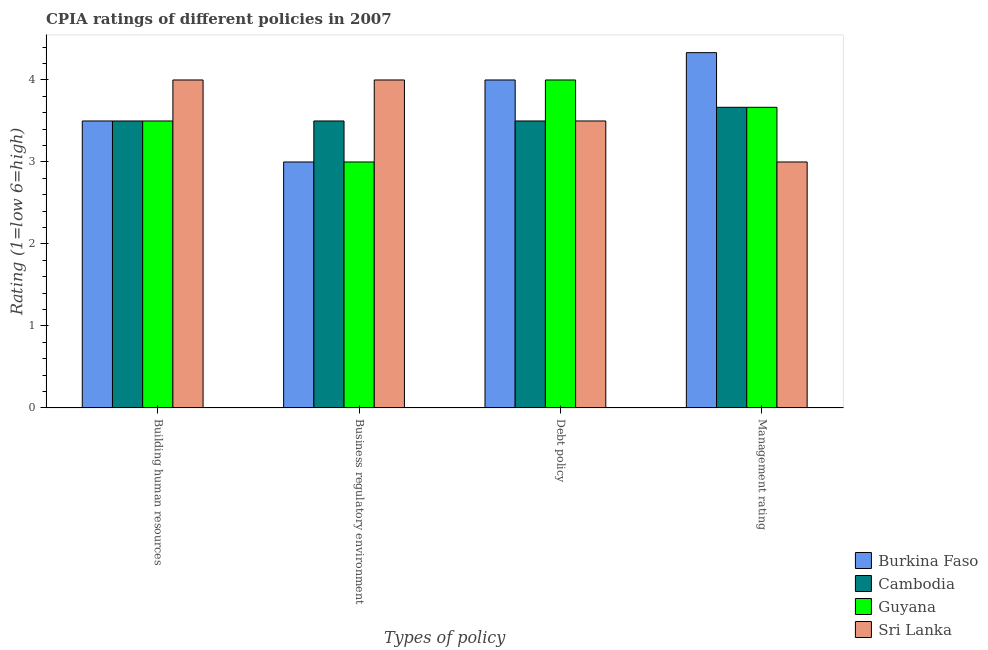How many different coloured bars are there?
Your answer should be very brief. 4. How many groups of bars are there?
Your answer should be compact. 4. How many bars are there on the 2nd tick from the right?
Provide a short and direct response. 4. What is the label of the 2nd group of bars from the left?
Offer a terse response. Business regulatory environment. Across all countries, what is the maximum cpia rating of debt policy?
Provide a short and direct response. 4. Across all countries, what is the minimum cpia rating of management?
Make the answer very short. 3. In which country was the cpia rating of management maximum?
Keep it short and to the point. Burkina Faso. In which country was the cpia rating of building human resources minimum?
Give a very brief answer. Burkina Faso. What is the difference between the cpia rating of building human resources in Sri Lanka and that in Guyana?
Your answer should be very brief. 0.5. What is the difference between the cpia rating of debt policy in Cambodia and the cpia rating of building human resources in Guyana?
Provide a short and direct response. 0. What is the average cpia rating of management per country?
Offer a very short reply. 3.67. In how many countries, is the cpia rating of business regulatory environment greater than 3.6 ?
Offer a very short reply. 1. What is the difference between the highest and the lowest cpia rating of business regulatory environment?
Give a very brief answer. 1. Is the sum of the cpia rating of building human resources in Burkina Faso and Sri Lanka greater than the maximum cpia rating of management across all countries?
Ensure brevity in your answer.  Yes. Is it the case that in every country, the sum of the cpia rating of debt policy and cpia rating of business regulatory environment is greater than the sum of cpia rating of building human resources and cpia rating of management?
Offer a very short reply. No. What does the 4th bar from the left in Building human resources represents?
Your response must be concise. Sri Lanka. What does the 3rd bar from the right in Debt policy represents?
Give a very brief answer. Cambodia. Is it the case that in every country, the sum of the cpia rating of building human resources and cpia rating of business regulatory environment is greater than the cpia rating of debt policy?
Provide a short and direct response. Yes. What is the difference between two consecutive major ticks on the Y-axis?
Ensure brevity in your answer.  1. Are the values on the major ticks of Y-axis written in scientific E-notation?
Keep it short and to the point. No. Does the graph contain any zero values?
Offer a very short reply. No. Does the graph contain grids?
Ensure brevity in your answer.  No. How many legend labels are there?
Ensure brevity in your answer.  4. What is the title of the graph?
Give a very brief answer. CPIA ratings of different policies in 2007. What is the label or title of the X-axis?
Ensure brevity in your answer.  Types of policy. What is the label or title of the Y-axis?
Make the answer very short. Rating (1=low 6=high). What is the Rating (1=low 6=high) of Cambodia in Building human resources?
Ensure brevity in your answer.  3.5. What is the Rating (1=low 6=high) of Burkina Faso in Business regulatory environment?
Your answer should be very brief. 3. What is the Rating (1=low 6=high) of Cambodia in Business regulatory environment?
Keep it short and to the point. 3.5. What is the Rating (1=low 6=high) of Sri Lanka in Business regulatory environment?
Your response must be concise. 4. What is the Rating (1=low 6=high) of Cambodia in Debt policy?
Keep it short and to the point. 3.5. What is the Rating (1=low 6=high) in Sri Lanka in Debt policy?
Ensure brevity in your answer.  3.5. What is the Rating (1=low 6=high) of Burkina Faso in Management rating?
Give a very brief answer. 4.33. What is the Rating (1=low 6=high) in Cambodia in Management rating?
Your answer should be very brief. 3.67. What is the Rating (1=low 6=high) in Guyana in Management rating?
Your response must be concise. 3.67. What is the Rating (1=low 6=high) in Sri Lanka in Management rating?
Your answer should be compact. 3. Across all Types of policy, what is the maximum Rating (1=low 6=high) of Burkina Faso?
Your response must be concise. 4.33. Across all Types of policy, what is the maximum Rating (1=low 6=high) of Cambodia?
Your answer should be compact. 3.67. Across all Types of policy, what is the maximum Rating (1=low 6=high) of Guyana?
Offer a terse response. 4. Across all Types of policy, what is the minimum Rating (1=low 6=high) of Cambodia?
Keep it short and to the point. 3.5. Across all Types of policy, what is the minimum Rating (1=low 6=high) of Guyana?
Provide a short and direct response. 3. What is the total Rating (1=low 6=high) in Burkina Faso in the graph?
Offer a very short reply. 14.83. What is the total Rating (1=low 6=high) of Cambodia in the graph?
Make the answer very short. 14.17. What is the total Rating (1=low 6=high) of Guyana in the graph?
Your answer should be very brief. 14.17. What is the difference between the Rating (1=low 6=high) of Burkina Faso in Building human resources and that in Business regulatory environment?
Your answer should be very brief. 0.5. What is the difference between the Rating (1=low 6=high) of Guyana in Building human resources and that in Business regulatory environment?
Your answer should be very brief. 0.5. What is the difference between the Rating (1=low 6=high) of Burkina Faso in Building human resources and that in Debt policy?
Provide a short and direct response. -0.5. What is the difference between the Rating (1=low 6=high) in Guyana in Building human resources and that in Debt policy?
Offer a very short reply. -0.5. What is the difference between the Rating (1=low 6=high) in Sri Lanka in Building human resources and that in Debt policy?
Your answer should be very brief. 0.5. What is the difference between the Rating (1=low 6=high) of Guyana in Building human resources and that in Management rating?
Give a very brief answer. -0.17. What is the difference between the Rating (1=low 6=high) in Burkina Faso in Business regulatory environment and that in Debt policy?
Keep it short and to the point. -1. What is the difference between the Rating (1=low 6=high) of Burkina Faso in Business regulatory environment and that in Management rating?
Your answer should be compact. -1.33. What is the difference between the Rating (1=low 6=high) in Cambodia in Business regulatory environment and that in Management rating?
Your response must be concise. -0.17. What is the difference between the Rating (1=low 6=high) of Burkina Faso in Debt policy and that in Management rating?
Keep it short and to the point. -0.33. What is the difference between the Rating (1=low 6=high) of Cambodia in Debt policy and that in Management rating?
Your answer should be compact. -0.17. What is the difference between the Rating (1=low 6=high) in Guyana in Debt policy and that in Management rating?
Your response must be concise. 0.33. What is the difference between the Rating (1=low 6=high) in Sri Lanka in Debt policy and that in Management rating?
Give a very brief answer. 0.5. What is the difference between the Rating (1=low 6=high) of Burkina Faso in Building human resources and the Rating (1=low 6=high) of Cambodia in Business regulatory environment?
Ensure brevity in your answer.  0. What is the difference between the Rating (1=low 6=high) of Burkina Faso in Building human resources and the Rating (1=low 6=high) of Guyana in Business regulatory environment?
Your answer should be compact. 0.5. What is the difference between the Rating (1=low 6=high) in Cambodia in Building human resources and the Rating (1=low 6=high) in Guyana in Business regulatory environment?
Give a very brief answer. 0.5. What is the difference between the Rating (1=low 6=high) in Cambodia in Building human resources and the Rating (1=low 6=high) in Sri Lanka in Business regulatory environment?
Ensure brevity in your answer.  -0.5. What is the difference between the Rating (1=low 6=high) of Burkina Faso in Building human resources and the Rating (1=low 6=high) of Guyana in Management rating?
Offer a terse response. -0.17. What is the difference between the Rating (1=low 6=high) in Burkina Faso in Building human resources and the Rating (1=low 6=high) in Sri Lanka in Management rating?
Ensure brevity in your answer.  0.5. What is the difference between the Rating (1=low 6=high) in Burkina Faso in Business regulatory environment and the Rating (1=low 6=high) in Cambodia in Debt policy?
Ensure brevity in your answer.  -0.5. What is the difference between the Rating (1=low 6=high) in Cambodia in Business regulatory environment and the Rating (1=low 6=high) in Sri Lanka in Debt policy?
Your response must be concise. 0. What is the difference between the Rating (1=low 6=high) in Guyana in Business regulatory environment and the Rating (1=low 6=high) in Sri Lanka in Debt policy?
Make the answer very short. -0.5. What is the difference between the Rating (1=low 6=high) of Burkina Faso in Business regulatory environment and the Rating (1=low 6=high) of Cambodia in Management rating?
Your answer should be very brief. -0.67. What is the difference between the Rating (1=low 6=high) in Burkina Faso in Business regulatory environment and the Rating (1=low 6=high) in Sri Lanka in Management rating?
Your answer should be very brief. 0. What is the difference between the Rating (1=low 6=high) in Cambodia in Business regulatory environment and the Rating (1=low 6=high) in Sri Lanka in Management rating?
Offer a very short reply. 0.5. What is the difference between the Rating (1=low 6=high) in Burkina Faso in Debt policy and the Rating (1=low 6=high) in Cambodia in Management rating?
Ensure brevity in your answer.  0.33. What is the difference between the Rating (1=low 6=high) of Burkina Faso in Debt policy and the Rating (1=low 6=high) of Guyana in Management rating?
Your answer should be very brief. 0.33. What is the difference between the Rating (1=low 6=high) in Burkina Faso in Debt policy and the Rating (1=low 6=high) in Sri Lanka in Management rating?
Provide a short and direct response. 1. What is the average Rating (1=low 6=high) in Burkina Faso per Types of policy?
Offer a very short reply. 3.71. What is the average Rating (1=low 6=high) in Cambodia per Types of policy?
Offer a very short reply. 3.54. What is the average Rating (1=low 6=high) of Guyana per Types of policy?
Ensure brevity in your answer.  3.54. What is the average Rating (1=low 6=high) in Sri Lanka per Types of policy?
Your answer should be very brief. 3.62. What is the difference between the Rating (1=low 6=high) in Burkina Faso and Rating (1=low 6=high) in Sri Lanka in Building human resources?
Your answer should be compact. -0.5. What is the difference between the Rating (1=low 6=high) in Cambodia and Rating (1=low 6=high) in Guyana in Building human resources?
Offer a very short reply. 0. What is the difference between the Rating (1=low 6=high) in Cambodia and Rating (1=low 6=high) in Sri Lanka in Building human resources?
Keep it short and to the point. -0.5. What is the difference between the Rating (1=low 6=high) of Burkina Faso and Rating (1=low 6=high) of Sri Lanka in Business regulatory environment?
Your answer should be very brief. -1. What is the difference between the Rating (1=low 6=high) of Cambodia and Rating (1=low 6=high) of Sri Lanka in Business regulatory environment?
Offer a terse response. -0.5. What is the difference between the Rating (1=low 6=high) of Guyana and Rating (1=low 6=high) of Sri Lanka in Business regulatory environment?
Give a very brief answer. -1. What is the difference between the Rating (1=low 6=high) of Burkina Faso and Rating (1=low 6=high) of Sri Lanka in Debt policy?
Your answer should be compact. 0.5. What is the difference between the Rating (1=low 6=high) in Burkina Faso and Rating (1=low 6=high) in Cambodia in Management rating?
Make the answer very short. 0.67. What is the difference between the Rating (1=low 6=high) of Burkina Faso and Rating (1=low 6=high) of Guyana in Management rating?
Give a very brief answer. 0.67. What is the difference between the Rating (1=low 6=high) in Burkina Faso and Rating (1=low 6=high) in Sri Lanka in Management rating?
Keep it short and to the point. 1.33. What is the difference between the Rating (1=low 6=high) of Cambodia and Rating (1=low 6=high) of Guyana in Management rating?
Provide a succinct answer. 0. What is the difference between the Rating (1=low 6=high) of Guyana and Rating (1=low 6=high) of Sri Lanka in Management rating?
Provide a succinct answer. 0.67. What is the ratio of the Rating (1=low 6=high) in Cambodia in Building human resources to that in Business regulatory environment?
Your answer should be compact. 1. What is the ratio of the Rating (1=low 6=high) in Guyana in Building human resources to that in Business regulatory environment?
Give a very brief answer. 1.17. What is the ratio of the Rating (1=low 6=high) in Burkina Faso in Building human resources to that in Debt policy?
Keep it short and to the point. 0.88. What is the ratio of the Rating (1=low 6=high) in Cambodia in Building human resources to that in Debt policy?
Keep it short and to the point. 1. What is the ratio of the Rating (1=low 6=high) in Guyana in Building human resources to that in Debt policy?
Give a very brief answer. 0.88. What is the ratio of the Rating (1=low 6=high) of Sri Lanka in Building human resources to that in Debt policy?
Offer a very short reply. 1.14. What is the ratio of the Rating (1=low 6=high) in Burkina Faso in Building human resources to that in Management rating?
Your response must be concise. 0.81. What is the ratio of the Rating (1=low 6=high) in Cambodia in Building human resources to that in Management rating?
Offer a terse response. 0.95. What is the ratio of the Rating (1=low 6=high) of Guyana in Building human resources to that in Management rating?
Keep it short and to the point. 0.95. What is the ratio of the Rating (1=low 6=high) of Cambodia in Business regulatory environment to that in Debt policy?
Provide a succinct answer. 1. What is the ratio of the Rating (1=low 6=high) of Guyana in Business regulatory environment to that in Debt policy?
Give a very brief answer. 0.75. What is the ratio of the Rating (1=low 6=high) of Burkina Faso in Business regulatory environment to that in Management rating?
Offer a very short reply. 0.69. What is the ratio of the Rating (1=low 6=high) in Cambodia in Business regulatory environment to that in Management rating?
Provide a short and direct response. 0.95. What is the ratio of the Rating (1=low 6=high) of Guyana in Business regulatory environment to that in Management rating?
Provide a succinct answer. 0.82. What is the ratio of the Rating (1=low 6=high) in Sri Lanka in Business regulatory environment to that in Management rating?
Offer a terse response. 1.33. What is the ratio of the Rating (1=low 6=high) in Cambodia in Debt policy to that in Management rating?
Keep it short and to the point. 0.95. What is the ratio of the Rating (1=low 6=high) of Sri Lanka in Debt policy to that in Management rating?
Keep it short and to the point. 1.17. What is the difference between the highest and the second highest Rating (1=low 6=high) in Burkina Faso?
Provide a short and direct response. 0.33. What is the difference between the highest and the lowest Rating (1=low 6=high) in Burkina Faso?
Ensure brevity in your answer.  1.33. What is the difference between the highest and the lowest Rating (1=low 6=high) of Cambodia?
Give a very brief answer. 0.17. What is the difference between the highest and the lowest Rating (1=low 6=high) of Guyana?
Make the answer very short. 1. 